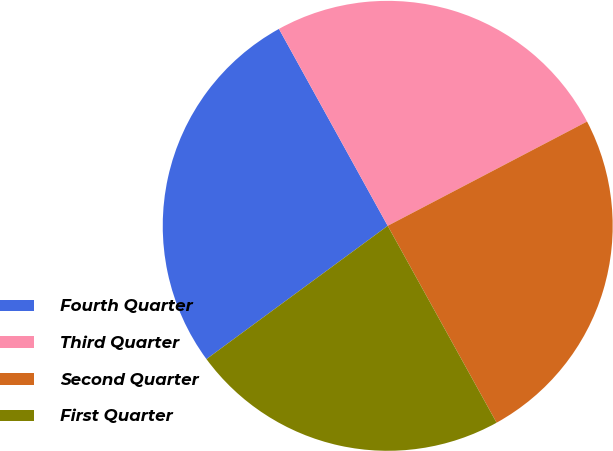Convert chart. <chart><loc_0><loc_0><loc_500><loc_500><pie_chart><fcel>Fourth Quarter<fcel>Third Quarter<fcel>Second Quarter<fcel>First Quarter<nl><fcel>27.06%<fcel>25.36%<fcel>24.63%<fcel>22.95%<nl></chart> 